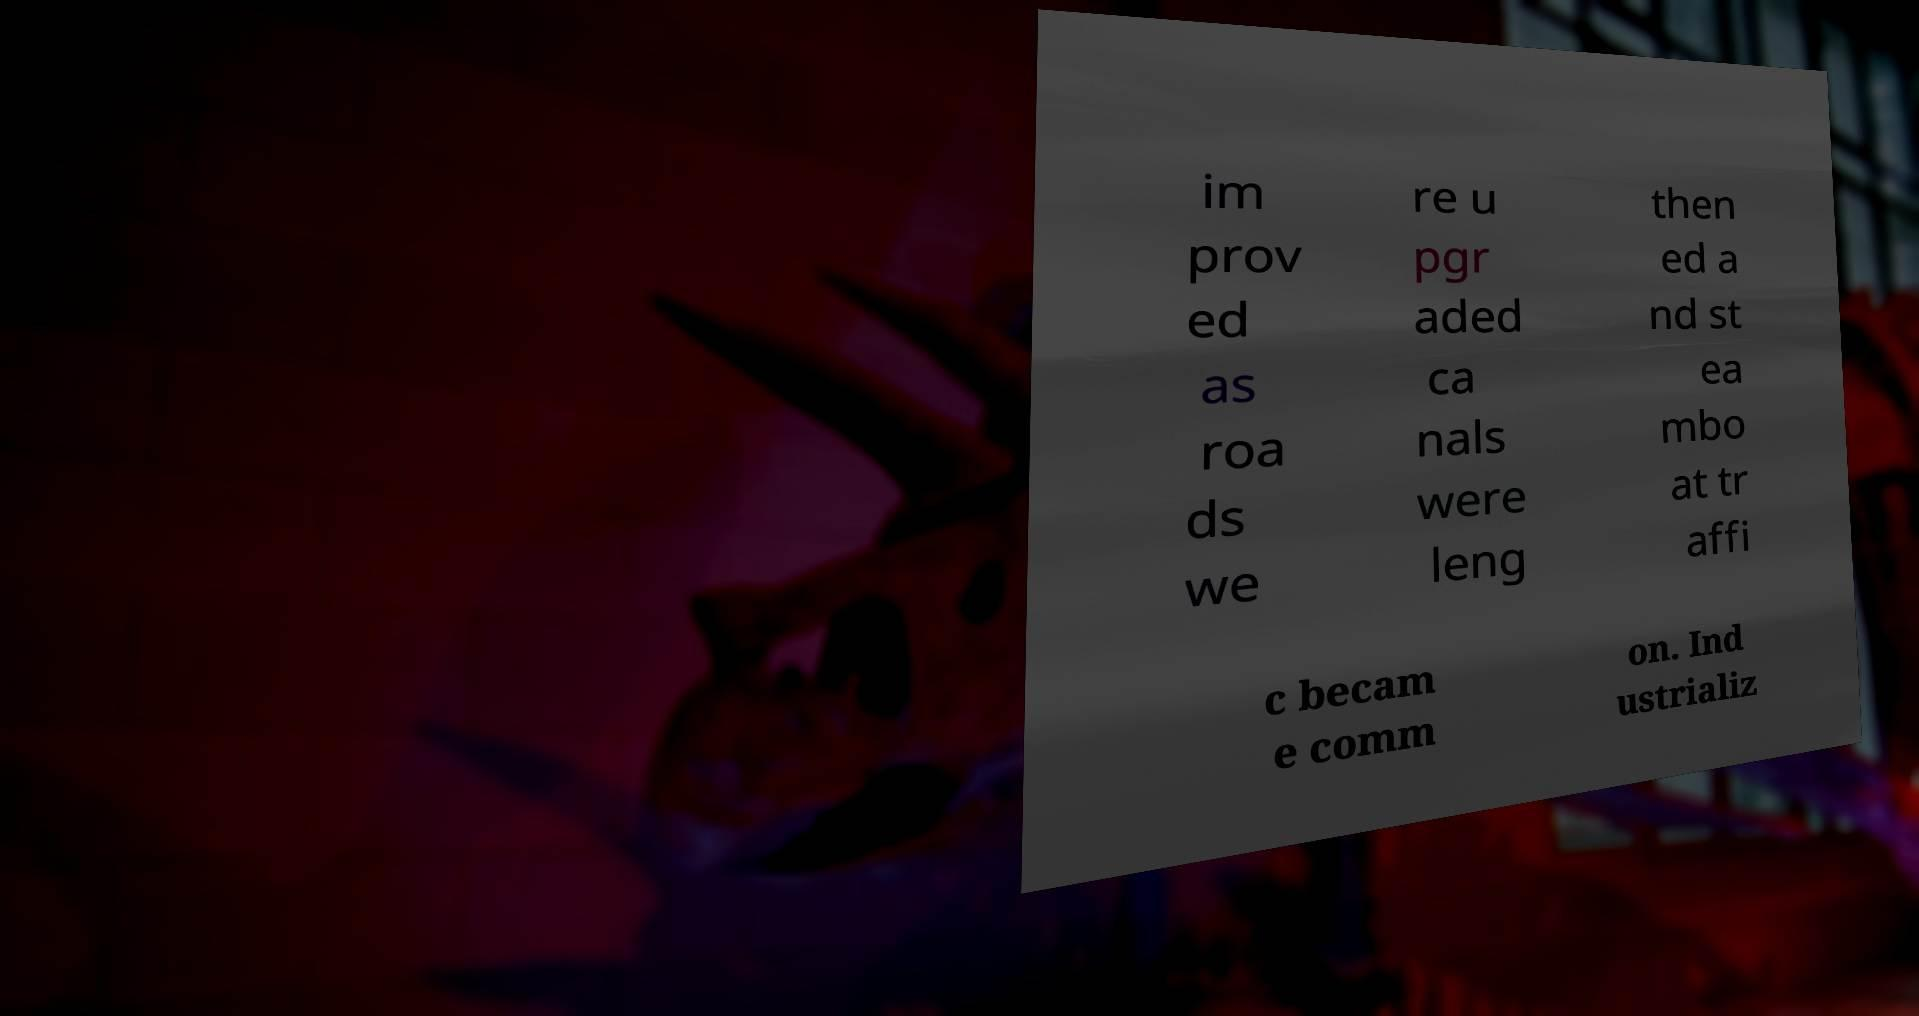Please identify and transcribe the text found in this image. im prov ed as roa ds we re u pgr aded ca nals were leng then ed a nd st ea mbo at tr affi c becam e comm on. Ind ustrializ 